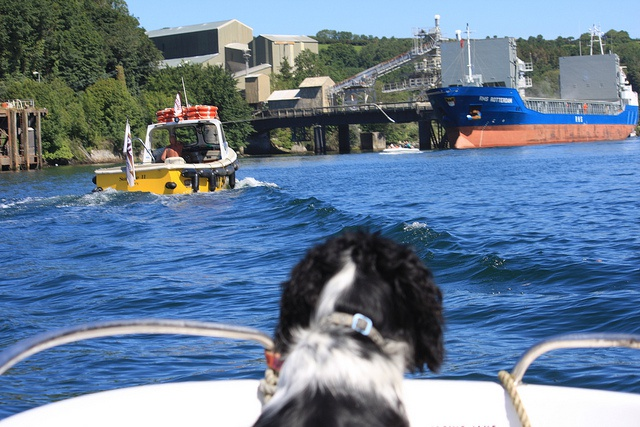Describe the objects in this image and their specific colors. I can see boat in darkgreen, white, blue, and gray tones, dog in darkgreen, black, lightgray, gray, and darkgray tones, boat in darkgreen, darkgray, salmon, blue, and black tones, boat in darkgreen, black, gray, white, and darkgray tones, and people in darkgreen, black, maroon, brown, and salmon tones in this image. 